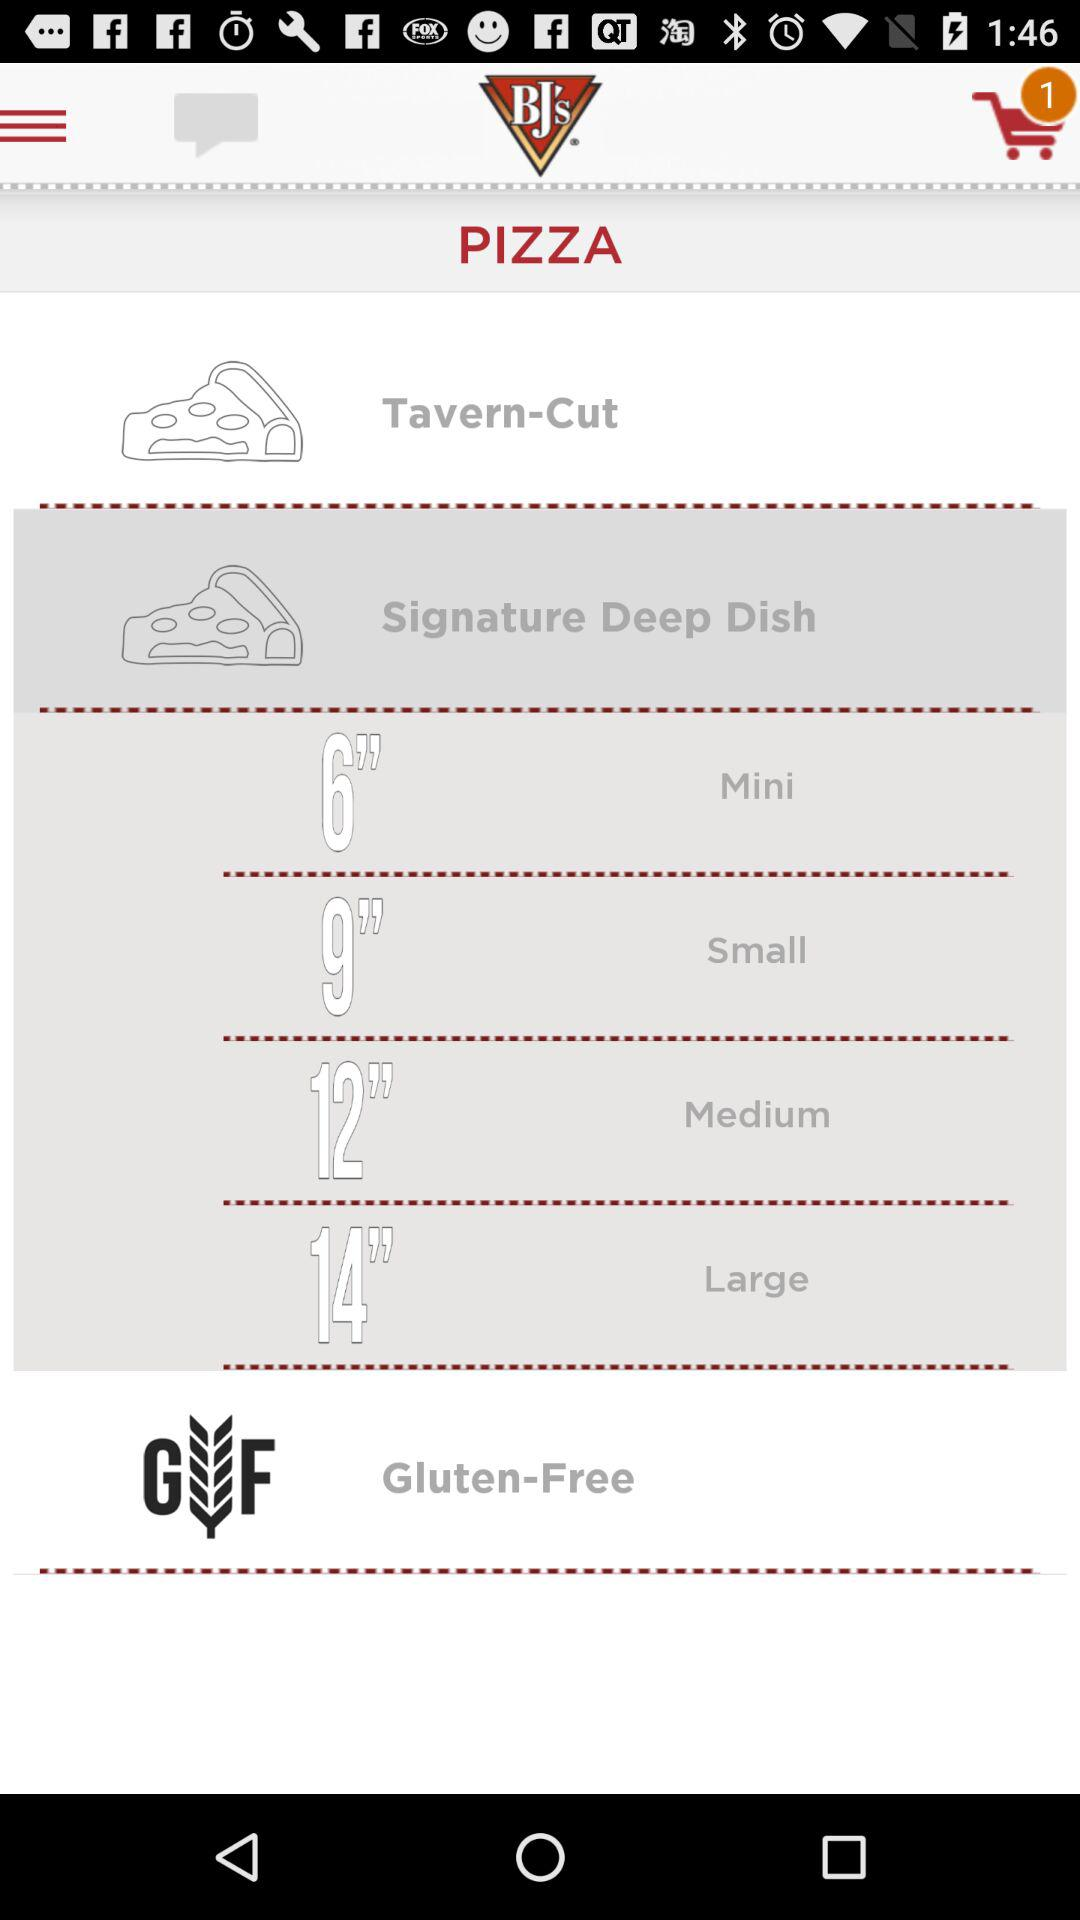Which pizza is 14 inches in size? The size of large pizza is 14 inches. 